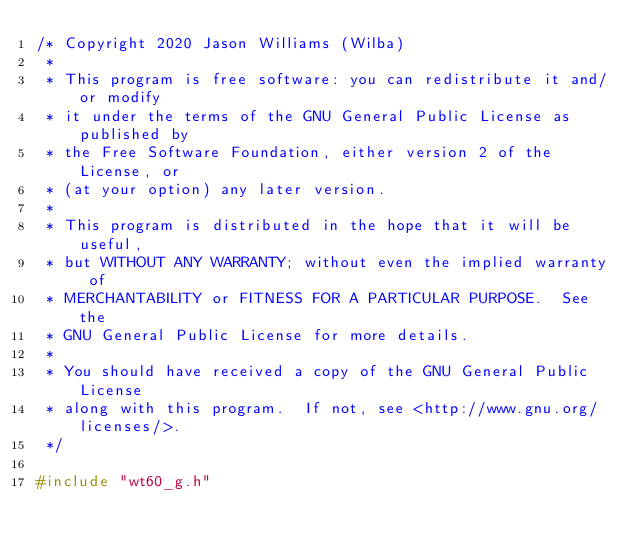<code> <loc_0><loc_0><loc_500><loc_500><_C_>/* Copyright 2020 Jason Williams (Wilba)
 *
 * This program is free software: you can redistribute it and/or modify
 * it under the terms of the GNU General Public License as published by
 * the Free Software Foundation, either version 2 of the License, or
 * (at your option) any later version.
 *
 * This program is distributed in the hope that it will be useful,
 * but WITHOUT ANY WARRANTY; without even the implied warranty of
 * MERCHANTABILITY or FITNESS FOR A PARTICULAR PURPOSE.  See the
 * GNU General Public License for more details.
 *
 * You should have received a copy of the GNU General Public License
 * along with this program.  If not, see <http://www.gnu.org/licenses/>.
 */

#include "wt60_g.h"
</code> 